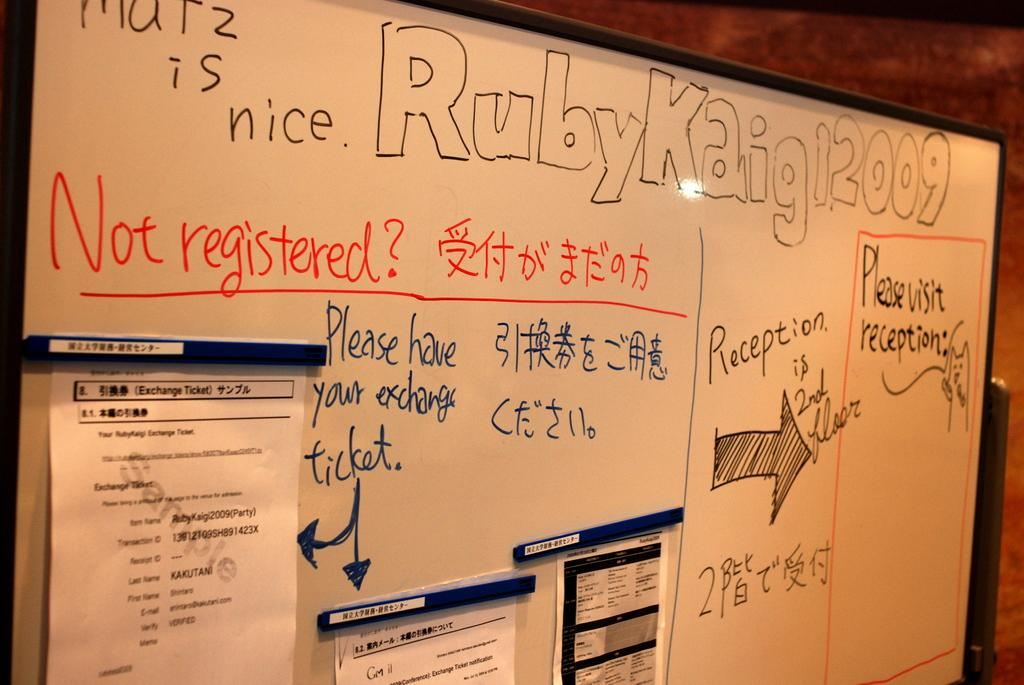Provide a one-sentence caption for the provided image. A white board with the words Ruby Kaigi12009 written across the top. 